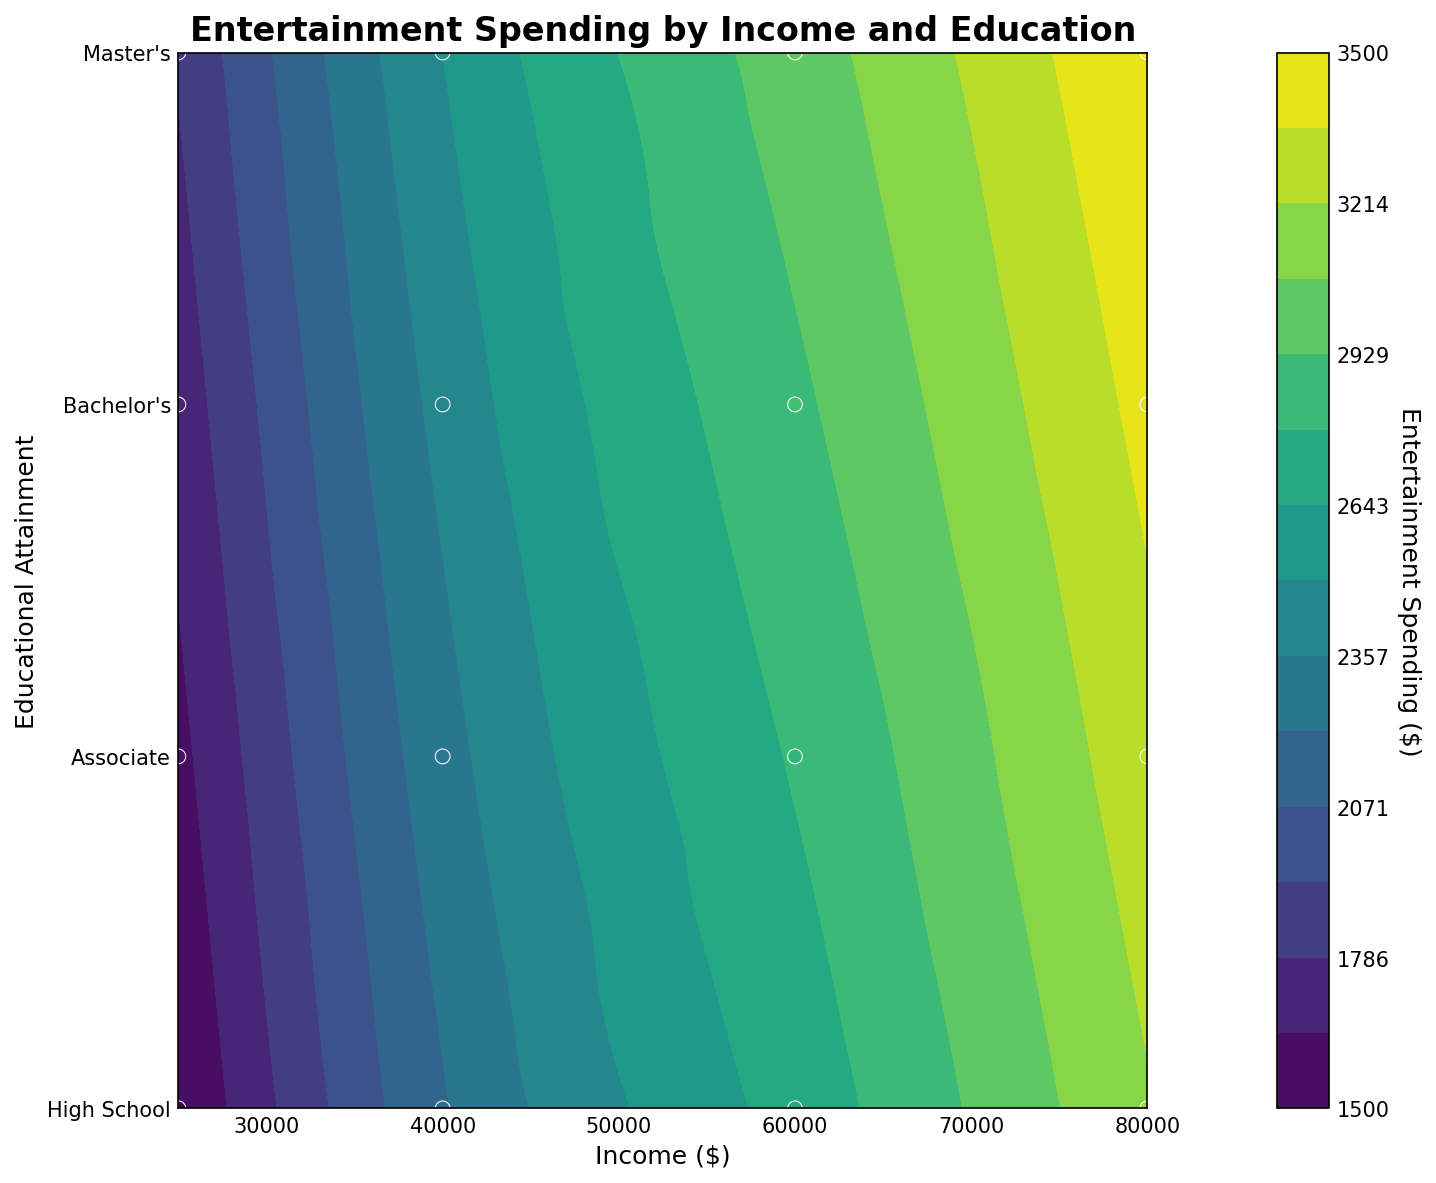What is the title of the figure? The title is typically placed at the top of the figure, usually in bold or larger font to stand out.
Answer: Entertainment Spending by Income and Education How is educational attainment represented on the y-axis? The y-axis uses numbers from 1 to 4, with corresponding labels for different levels of education ('High School', 'Associate', 'Bachelor's', 'Master's').
Answer: Levels from 1 to 4 with labels for different educational attainments What does the color gradient represent in this figure? The color gradient represents the level of entertainment spending, with the exact amounts indicated by the color bar on the side.
Answer: Entertainment spending in dollars Which income level has the highest entertainment spending for individuals with a Master's degree? To determine this, look at the contour levels and color intensity at the y-coordinate corresponding to 'Master's Degree' (4) and find the maximum point along the x-axis (income).
Answer: $80,000 At what educational level and income is the lowest entertainment spending observed? The lowest entertainment spending will be shown by the lightest colors. Look at the lightest regions in the contour and map them to the corresponding y (education) and x (income) values.
Answer: High School, $25,000 What trend is observed in entertainment spending as income increases for those with a Bachelor's degree? Follow the contour lines or color changes along the y-coordinate for 'Bachelor's Degree' (3) as the x-axis (income) increases. Note how spending changes.
Answer: It increases Compare the entertainment spending between someone with an Associate Degree earning $60,000 and someone with a High School diploma earning $80,000. Find the corresponding points on the plot for these educational levels and incomes. Check the color intensity or contour levels.
Answer: Spending is higher for High School diploma at $80,000 Is the relationship between income and entertainment spending more significant or educational attainment and entertainment spending more significant? Examine the spread and separation of color gradients along each axis. Determine which axis changes lead to more significant variations in spending.
Answer: Income shows a more significant relationship How does the spending on entertainment compare between individuals with a Master's Degree earning $40,000 and those with a Bachelor's Degree earning $60,000? Find these data points on the contour plot and compare the color intensity or contour level for each point.
Answer: Master's Degree at $40,000 Based on the contour plot, what can be inferred about the impact of higher education on entertainment spending? Observe how the entertainment spending changes as you move up the education levels at a fixed income. Assess the general trend in the color gradient.
Answer: Higher education generally corresponds to higher spending 